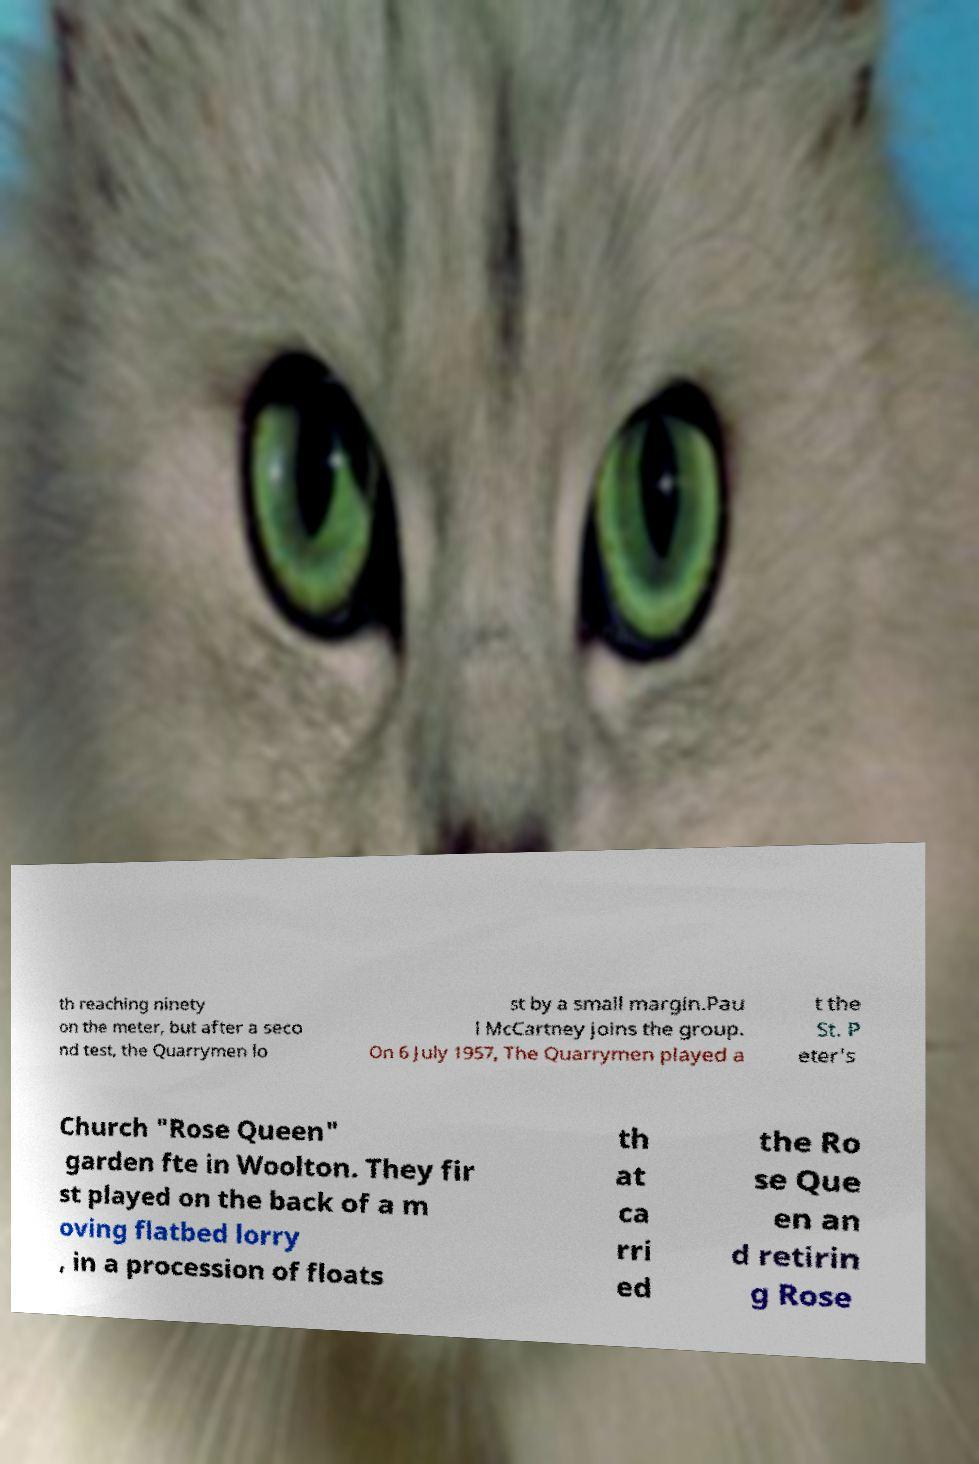There's text embedded in this image that I need extracted. Can you transcribe it verbatim? th reaching ninety on the meter, but after a seco nd test, the Quarrymen lo st by a small margin.Pau l McCartney joins the group. On 6 July 1957, The Quarrymen played a t the St. P eter's Church "Rose Queen" garden fte in Woolton. They fir st played on the back of a m oving flatbed lorry , in a procession of floats th at ca rri ed the Ro se Que en an d retirin g Rose 